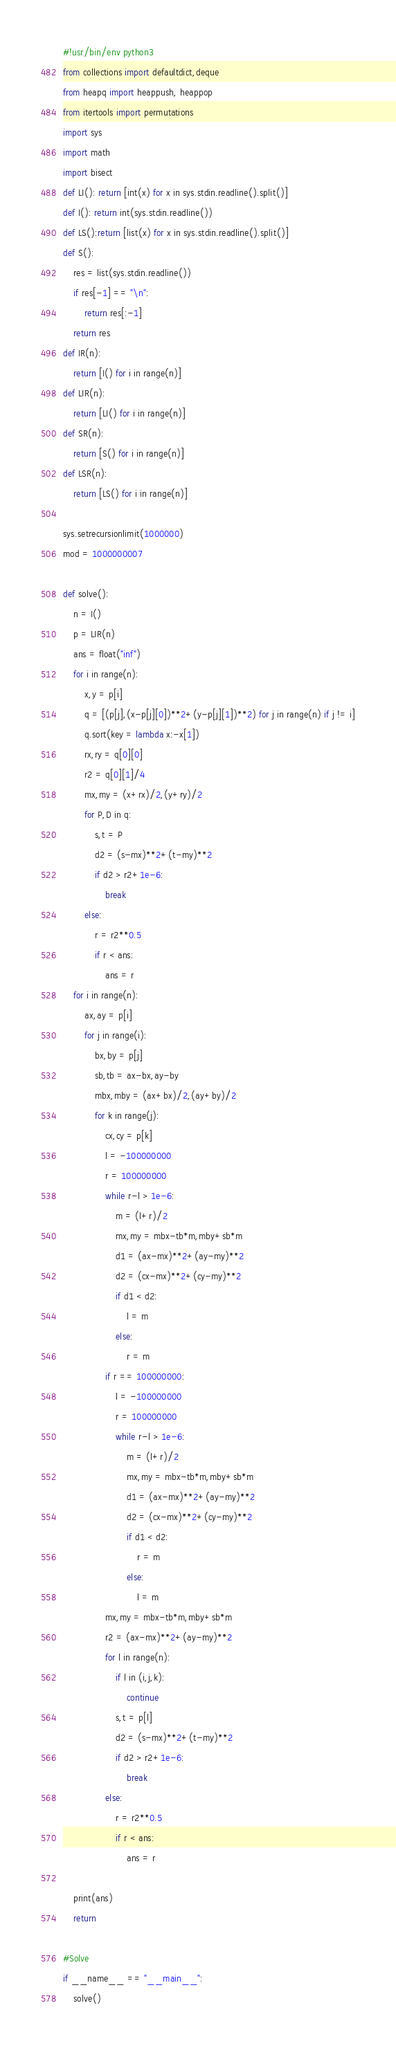Convert code to text. <code><loc_0><loc_0><loc_500><loc_500><_Python_>#!usr/bin/env python3
from collections import defaultdict,deque
from heapq import heappush, heappop
from itertools import permutations
import sys
import math
import bisect
def LI(): return [int(x) for x in sys.stdin.readline().split()]
def I(): return int(sys.stdin.readline())
def LS():return [list(x) for x in sys.stdin.readline().split()]
def S():
    res = list(sys.stdin.readline())
    if res[-1] == "\n":
        return res[:-1]
    return res
def IR(n):
    return [I() for i in range(n)]
def LIR(n):
    return [LI() for i in range(n)]
def SR(n):
    return [S() for i in range(n)]
def LSR(n):
    return [LS() for i in range(n)]

sys.setrecursionlimit(1000000)
mod = 1000000007

def solve():
    n = I()
    p = LIR(n)
    ans = float("inf")
    for i in range(n):
        x,y = p[i]
        q = [(p[j],(x-p[j][0])**2+(y-p[j][1])**2) for j in range(n) if j != i]
        q.sort(key = lambda x:-x[1])
        rx,ry = q[0][0]
        r2 = q[0][1]/4
        mx,my = (x+rx)/2,(y+ry)/2
        for P,D in q:
            s,t = P
            d2 = (s-mx)**2+(t-my)**2
            if d2 > r2+1e-6:
                break
        else:
            r = r2**0.5
            if r < ans:
                ans = r
    for i in range(n):
        ax,ay = p[i]
        for j in range(i):
            bx,by = p[j]
            sb,tb = ax-bx,ay-by
            mbx,mby = (ax+bx)/2,(ay+by)/2
            for k in range(j):
                cx,cy = p[k]
                l = -100000000
                r = 100000000
                while r-l > 1e-6:
                    m = (l+r)/2
                    mx,my = mbx-tb*m,mby+sb*m
                    d1 = (ax-mx)**2+(ay-my)**2
                    d2 = (cx-mx)**2+(cy-my)**2
                    if d1 < d2:
                        l = m
                    else:
                        r = m
                if r == 100000000:
                    l = -100000000
                    r = 100000000
                    while r-l > 1e-6:
                        m = (l+r)/2
                        mx,my = mbx-tb*m,mby+sb*m
                        d1 = (ax-mx)**2+(ay-my)**2
                        d2 = (cx-mx)**2+(cy-my)**2
                        if d1 < d2:
                            r = m
                        else:
                            l = m
                mx,my = mbx-tb*m,mby+sb*m
                r2 = (ax-mx)**2+(ay-my)**2
                for l in range(n):
                    if l in (i,j,k):
                        continue
                    s,t = p[l]
                    d2 = (s-mx)**2+(t-my)**2
                    if d2 > r2+1e-6:
                        break
                else:
                    r = r2**0.5
                    if r < ans:
                        ans = r

    print(ans)
    return

#Solve
if __name__ == "__main__":
    solve()
</code> 